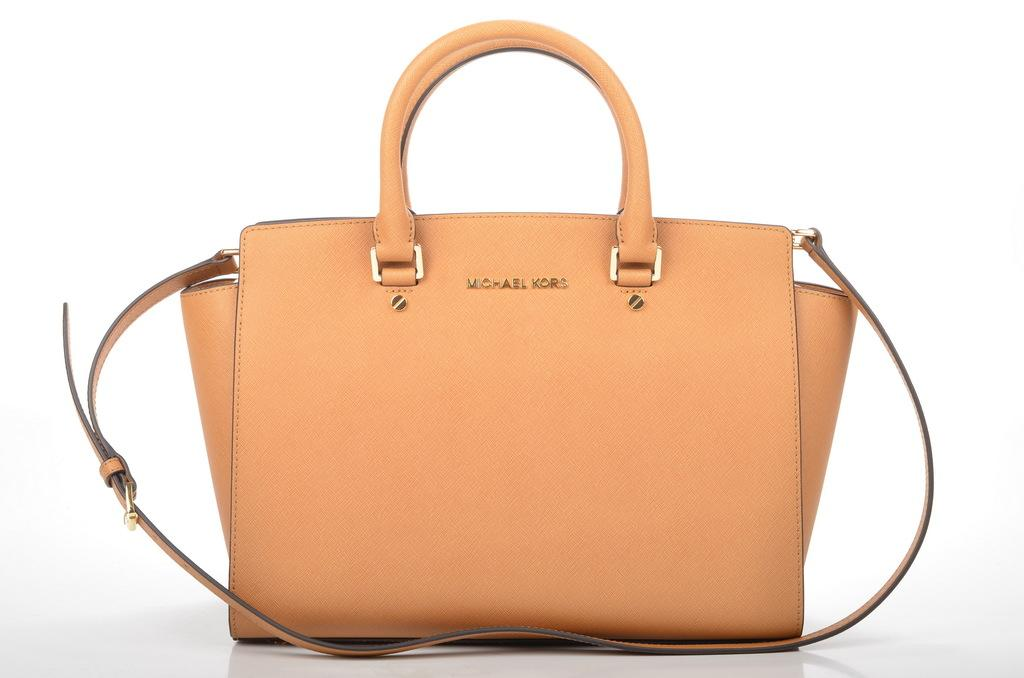What color is the handbag in the image? The handbag is peach-colored. How is the handbag being emphasized in the image? The handbag is highlighted. What is the color of the surface on which the handbag is placed? The handbag is placed on a white surface. What type of camera is being used to take the picture of the handbag? There is no information about a camera being used to take the picture of the handbag in the image. 